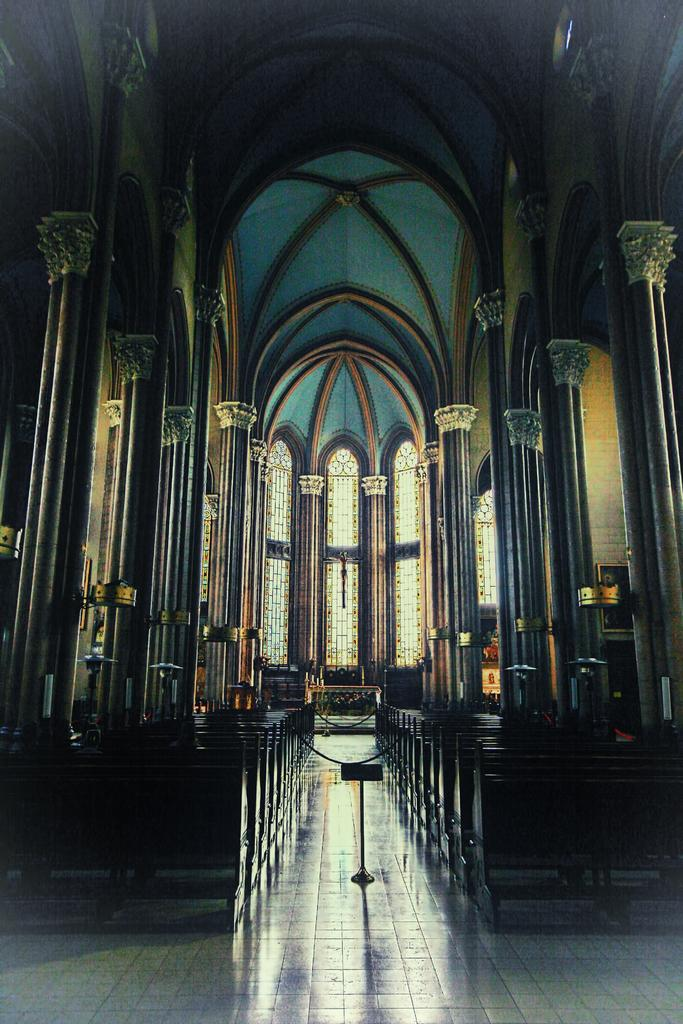Where is the location of the image? The image is inside a building. What architectural features can be seen in the image? There are pillars in the image. What allows natural light to enter the building in the image? There are windows in the image. What is present for people to stand or display items in the image? There is a stand in the image. What can people sit on in the image? There are benches in the image. What decorative elements are on the walls in the image? There are pictures on the walls in the image. Can you see any elbows in the image? There are no elbows visible in the image. Are there any ducks swimming in the image? There are no ducks or any swimming activity depicted in the image. Is there a yak present in the image? There are no yaks or any yak-related elements in the image. 